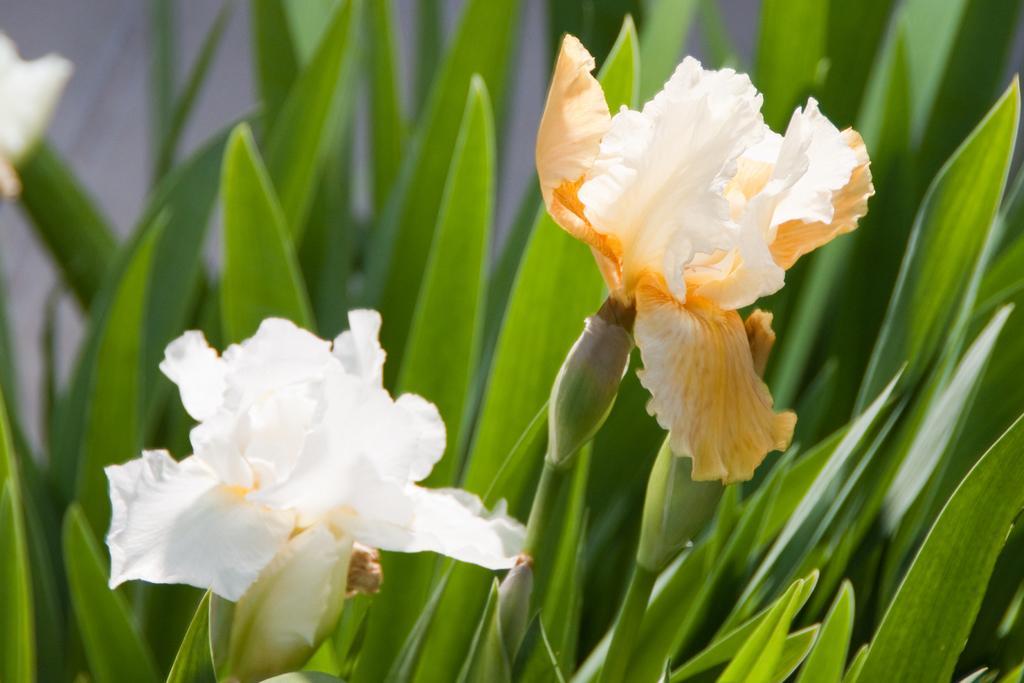How would you summarize this image in a sentence or two? There are plants. Some of them are having flowers. In the background, there are leaves of of the plants. And the background is white in color. 